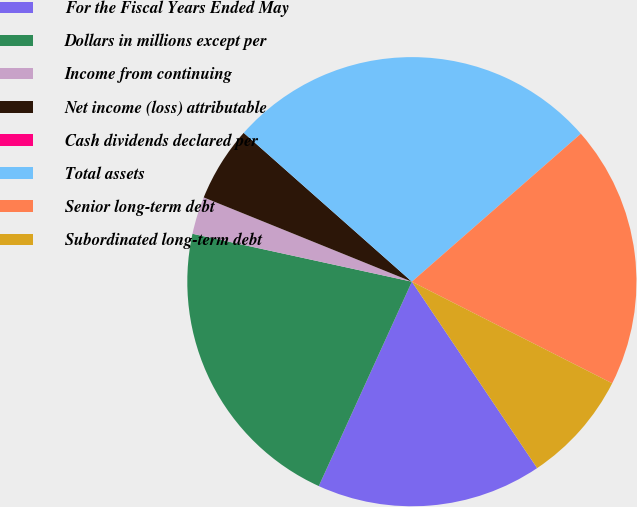Convert chart to OTSL. <chart><loc_0><loc_0><loc_500><loc_500><pie_chart><fcel>For the Fiscal Years Ended May<fcel>Dollars in millions except per<fcel>Income from continuing<fcel>Net income (loss) attributable<fcel>Cash dividends declared per<fcel>Total assets<fcel>Senior long-term debt<fcel>Subordinated long-term debt<nl><fcel>16.22%<fcel>21.62%<fcel>2.7%<fcel>5.41%<fcel>0.0%<fcel>27.02%<fcel>18.92%<fcel>8.11%<nl></chart> 